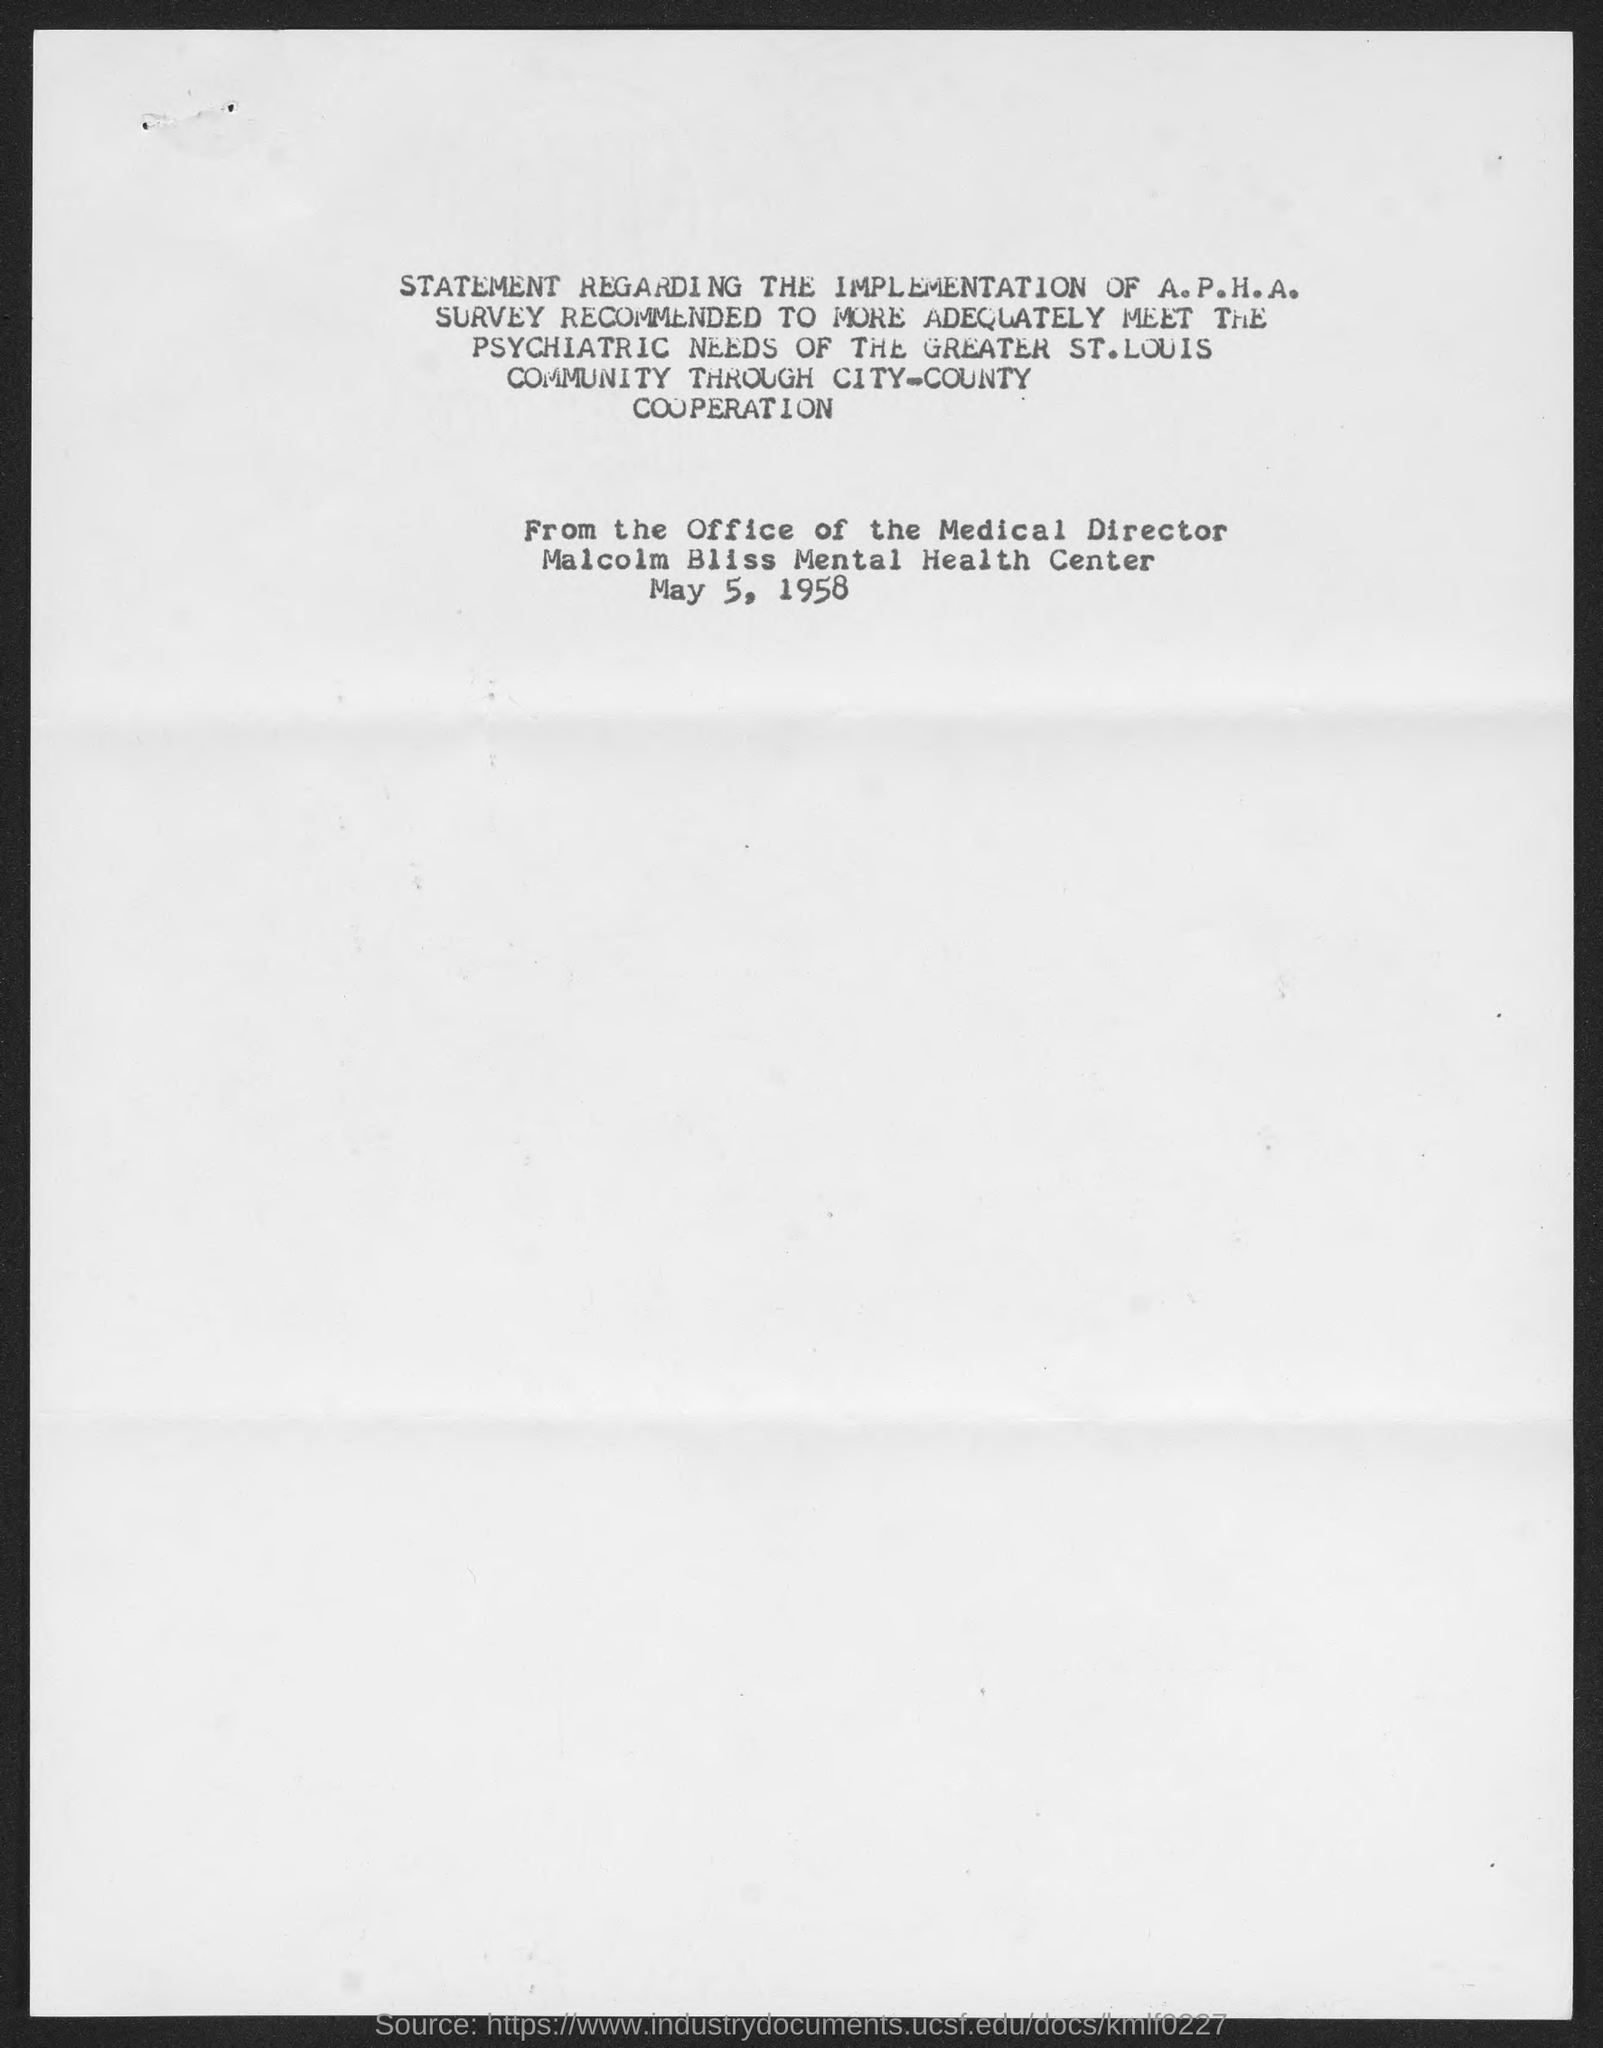What is the date mentioned in the document?
Offer a terse response. May 5, 1958. What is the name of the mental health center?
Provide a succinct answer. Malcolm Bliss Mental Health  Center. 